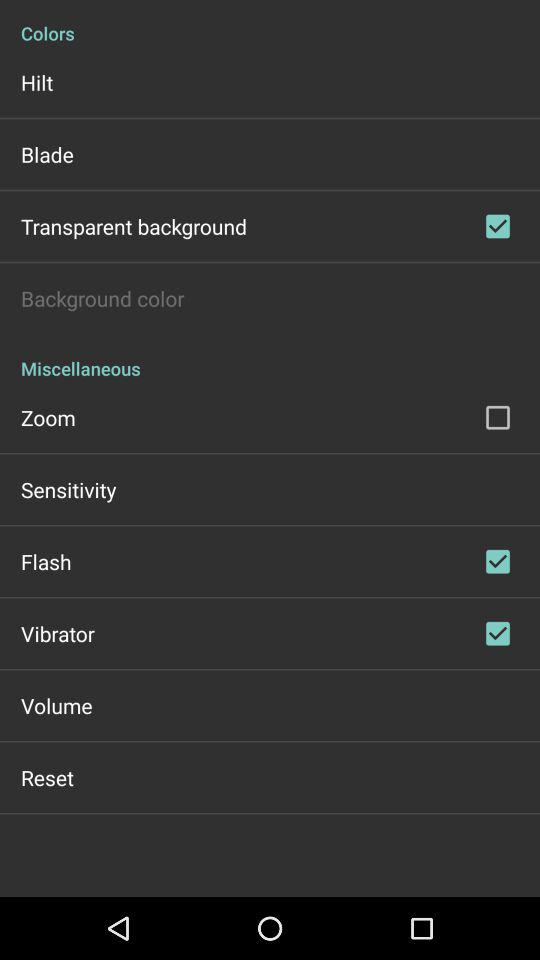What is the status of the zoom? The status is off. 